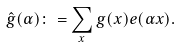<formula> <loc_0><loc_0><loc_500><loc_500>\hat { g } ( \alpha ) \colon = \sum _ { x } g ( x ) e ( \alpha x ) .</formula> 